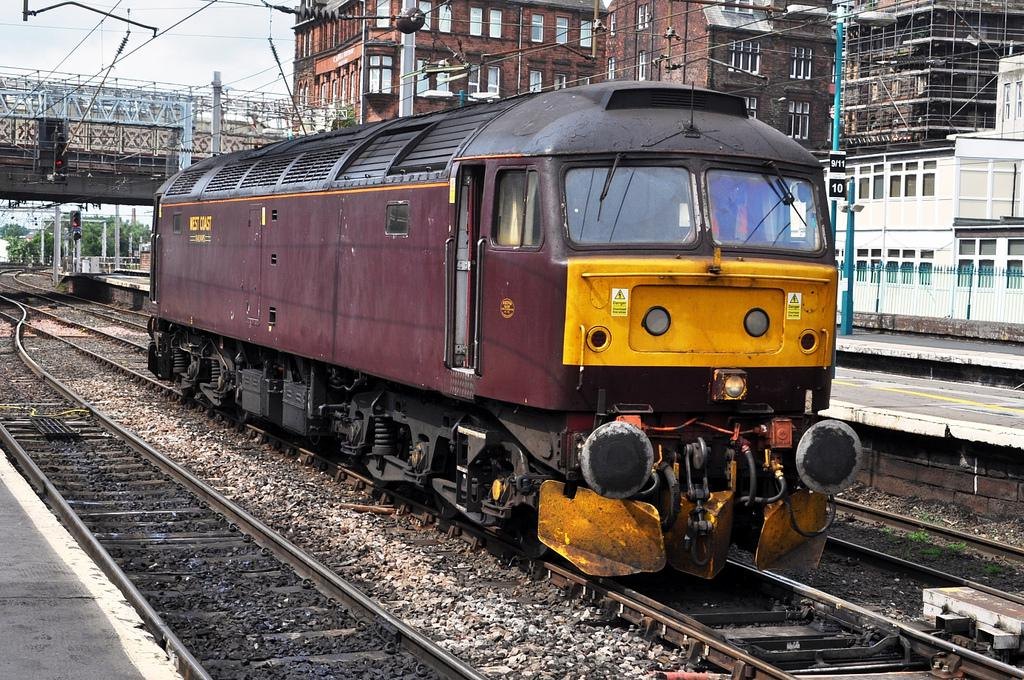Question: what two colors is the train?
Choices:
A. Black and white.
B. Orange and blue.
C. Red and yellow.
D. Pink and purple.
Answer with the letter. Answer: C Question: what is the structue built above the tracks?
Choices:
A. A tower.
B. A bridge.
C. A train station.
D. A restaurant.
Answer with the letter. Answer: B Question: what set of tracks is the train on?
Choices:
A. The right.
B. The left.
C. The west.
D. The middle.
Answer with the letter. Answer: D Question: how many doors are on the train?
Choices:
A. 3.
B. 2.
C. 5.
D. 7.
Answer with the letter. Answer: B Question: where is this picture taken?
Choices:
A. Train tracks.
B. Conference room.
C. Nursery.
D. Coal mine.
Answer with the letter. Answer: A Question: how many tracks are there?
Choices:
A. Two.
B. One.
C. Three.
D. Four.
Answer with the letter. Answer: C Question: what color is the front of the train?
Choices:
A. Red.
B. Yellow.
C. Black.
D. Green.
Answer with the letter. Answer: B Question: what is above the tracks?
Choices:
A. Power lines.
B. Telephone lines.
C. A balloon.
D. Cable lines.
Answer with the letter. Answer: D Question: where was the photo taken?
Choices:
A. Bus station.
B. Airport.
C. Train tracks.
D. Taxi stand.
Answer with the letter. Answer: C Question: how many trains are there?
Choices:
A. One train.
B. Two trains.
C. No trains.
D. Five trains.
Answer with the letter. Answer: A Question: what is pulling no cars behind it?
Choices:
A. Truck.
B. Wrecker.
C. Bus.
D. Train.
Answer with the letter. Answer: D Question: how many people are here?
Choices:
A. None.
B. Two.
C. Six.
D. Four.
Answer with the letter. Answer: A Question: how many sets of train tracks are there?
Choices:
A. Six.
B. Two.
C. Five.
D. Four.
Answer with the letter. Answer: B Question: what has few clouds?
Choices:
A. The sky.
B. Pictures.
C. Movies.
D. Sunny days.
Answer with the letter. Answer: A Question: how many train tracks do you see?
Choices:
A. 1.
B. 3.
C. 2.
D. 4.
Answer with the letter. Answer: B Question: what is on tracks?
Choices:
A. Rocks.
B. Nails.
C. Railroad ties.
D. Wooden planks.
Answer with the letter. Answer: C Question: what has two headlights?
Choices:
A. Car.
B. Bus.
C. Van.
D. Train.
Answer with the letter. Answer: D Question: what are parallel to each other?
Choices:
A. The trees.
B. The roads.
C. The rocks.
D. The tracks.
Answer with the letter. Answer: D Question: how many train tracks are shown?
Choices:
A. 4.
B. 3.
C. 5.
D. 6.
Answer with the letter. Answer: B Question: what is mostly maroon?
Choices:
A. Train.
B. Bus.
C. Car.
D. Truck.
Answer with the letter. Answer: A Question: what kind of scene is it?
Choices:
A. Night time.
B. Beach.
C. Christmas.
D. Daytime.
Answer with the letter. Answer: D 